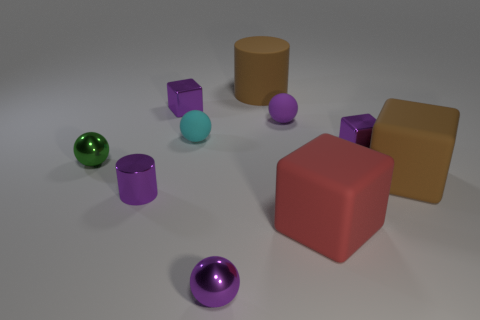The tiny matte thing that is the same color as the metallic cylinder is what shape?
Give a very brief answer. Sphere. Are the purple thing that is behind the small purple rubber object and the big cylinder made of the same material?
Give a very brief answer. No. There is another tiny matte thing that is the same shape as the small purple matte thing; what color is it?
Provide a short and direct response. Cyan. Is there any other thing that is the same shape as the small green thing?
Your response must be concise. Yes. Is the number of large brown objects that are behind the cyan ball the same as the number of purple balls?
Your response must be concise. No. There is a tiny green metal thing; are there any purple objects on the right side of it?
Your answer should be very brief. Yes. How big is the metal cube that is to the right of the tiny purple metal block that is left of the small purple ball in front of the large red cube?
Offer a terse response. Small. There is a big brown object that is in front of the big brown cylinder; is it the same shape as the big brown matte thing that is behind the green metal ball?
Your answer should be compact. No. What size is the other metal object that is the same shape as the small green thing?
Your response must be concise. Small. What number of brown things are made of the same material as the red object?
Provide a succinct answer. 2. 